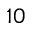<formula> <loc_0><loc_0><loc_500><loc_500>1 0</formula> 